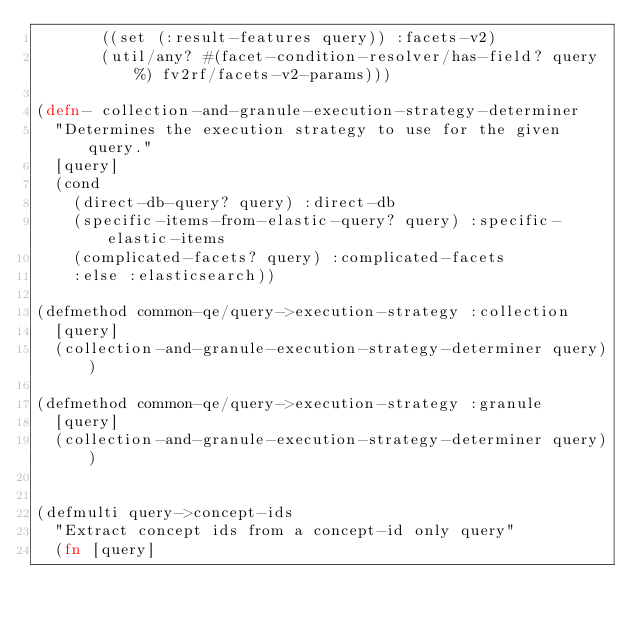<code> <loc_0><loc_0><loc_500><loc_500><_Clojure_>       ((set (:result-features query)) :facets-v2)
       (util/any? #(facet-condition-resolver/has-field? query %) fv2rf/facets-v2-params)))

(defn- collection-and-granule-execution-strategy-determiner
  "Determines the execution strategy to use for the given query."
  [query]
  (cond
    (direct-db-query? query) :direct-db
    (specific-items-from-elastic-query? query) :specific-elastic-items
    (complicated-facets? query) :complicated-facets
    :else :elasticsearch))

(defmethod common-qe/query->execution-strategy :collection
  [query]
  (collection-and-granule-execution-strategy-determiner query))

(defmethod common-qe/query->execution-strategy :granule
  [query]
  (collection-and-granule-execution-strategy-determiner query))


(defmulti query->concept-ids
  "Extract concept ids from a concept-id only query"
  (fn [query]</code> 